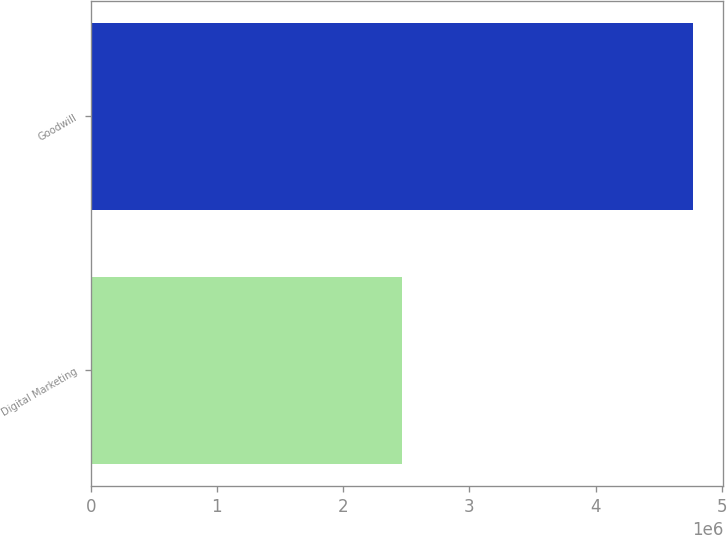Convert chart to OTSL. <chart><loc_0><loc_0><loc_500><loc_500><bar_chart><fcel>Digital Marketing<fcel>Goodwill<nl><fcel>2.46383e+06<fcel>4.77198e+06<nl></chart> 